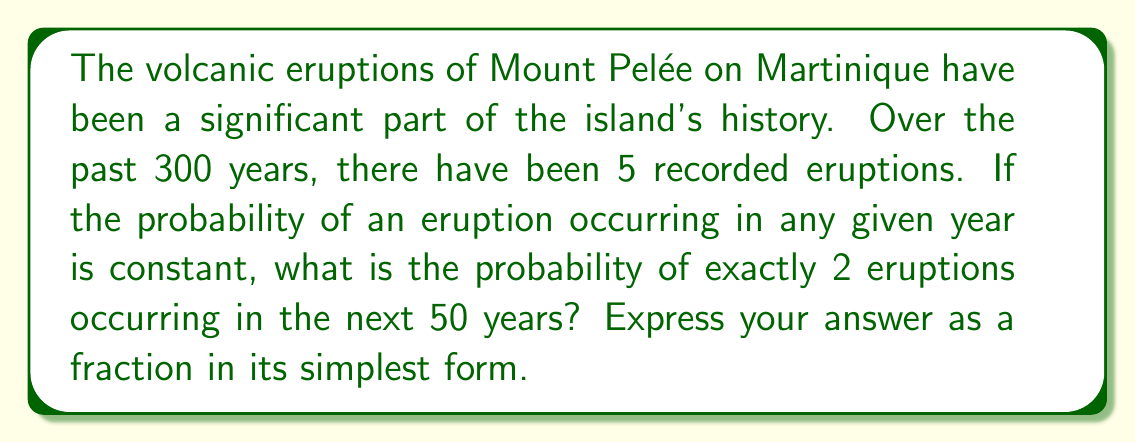Show me your answer to this math problem. To solve this problem, we'll use the Binomial Probability Formula:

$$P(X = k) = \binom{n}{k} p^k (1-p)^{n-k}$$

Where:
- $n$ is the number of trials (years)
- $k$ is the number of successes (eruptions)
- $p$ is the probability of success on each trial

Step 1: Calculate the probability of an eruption in any given year.
$p = \frac{5 \text{ eruptions}}{300 \text{ years}} = \frac{1}{60}$

Step 2: Identify the values for our formula.
$n = 50$ (next 50 years)
$k = 2$ (exactly 2 eruptions)
$p = \frac{1}{60}$

Step 3: Calculate $\binom{n}{k}$
$$\binom{50}{2} = \frac{50!}{2!(50-2)!} = \frac{50 \cdot 49}{2} = 1225$$

Step 4: Apply the Binomial Probability Formula
$$P(X = 2) = 1225 \cdot (\frac{1}{60})^2 \cdot (1-\frac{1}{60})^{48}$$

Step 5: Simplify
$$P(X = 2) = 1225 \cdot \frac{1}{3600} \cdot (\frac{59}{60})^{48}$$

$$P(X = 2) = \frac{1225}{3600} \cdot (\frac{59}{60})^{48}$$

Step 6: Calculate the final value (rounded to 9 decimal places)
$$P(X = 2) \approx 0.183964249$$

Step 7: Convert to a fraction
$$P(X = 2) = \frac{183964249}{1000000000}$$
Answer: $\frac{183964249}{1000000000}$ 